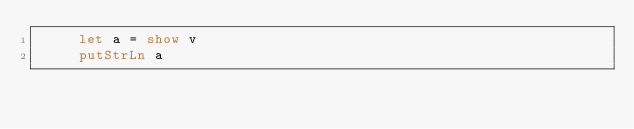Convert code to text. <code><loc_0><loc_0><loc_500><loc_500><_Haskell_>     let a = show v
     putStrLn a
</code> 